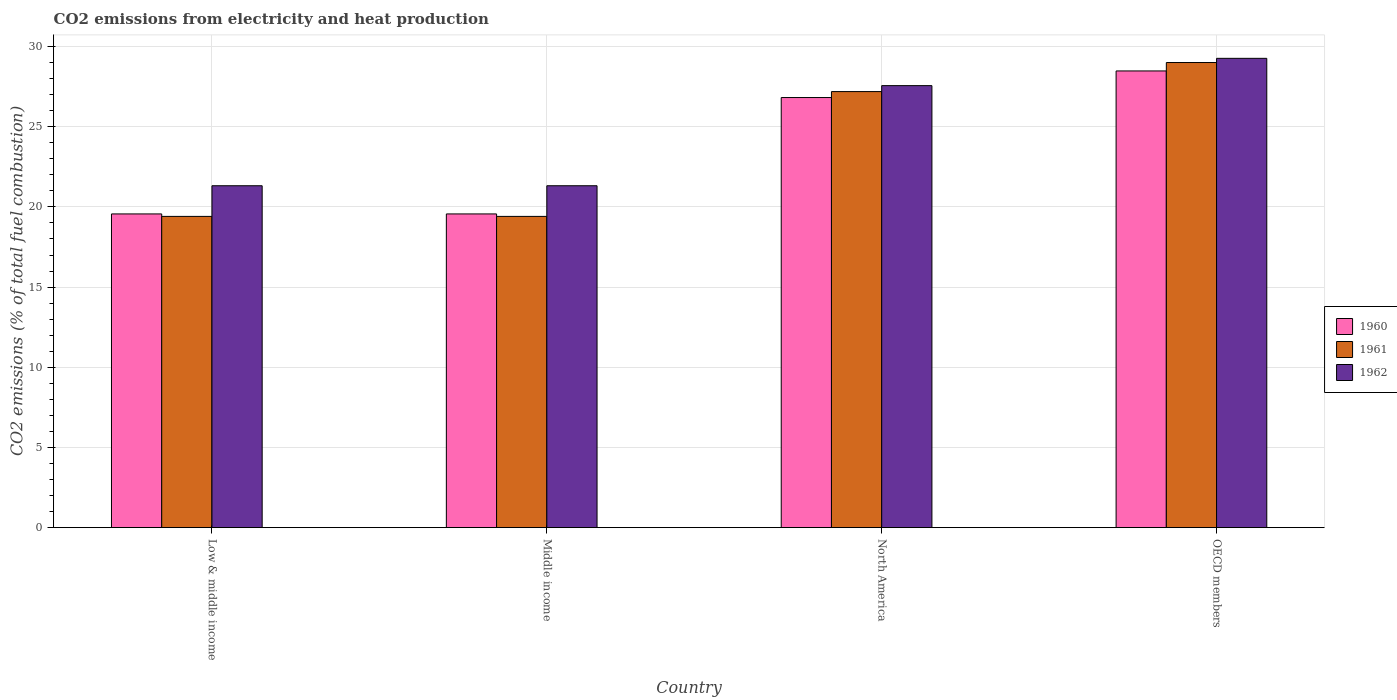How many different coloured bars are there?
Offer a very short reply. 3. How many bars are there on the 4th tick from the left?
Provide a succinct answer. 3. How many bars are there on the 3rd tick from the right?
Your answer should be compact. 3. What is the amount of CO2 emitted in 1961 in OECD members?
Keep it short and to the point. 29. Across all countries, what is the maximum amount of CO2 emitted in 1962?
Offer a terse response. 29.26. Across all countries, what is the minimum amount of CO2 emitted in 1962?
Offer a terse response. 21.32. In which country was the amount of CO2 emitted in 1960 maximum?
Provide a succinct answer. OECD members. In which country was the amount of CO2 emitted in 1961 minimum?
Offer a terse response. Low & middle income. What is the total amount of CO2 emitted in 1960 in the graph?
Your answer should be compact. 94.43. What is the difference between the amount of CO2 emitted in 1961 in North America and that in OECD members?
Your answer should be very brief. -1.81. What is the difference between the amount of CO2 emitted in 1960 in Middle income and the amount of CO2 emitted in 1962 in OECD members?
Make the answer very short. -9.7. What is the average amount of CO2 emitted in 1962 per country?
Make the answer very short. 24.87. What is the difference between the amount of CO2 emitted of/in 1962 and amount of CO2 emitted of/in 1961 in Low & middle income?
Your response must be concise. 1.91. In how many countries, is the amount of CO2 emitted in 1960 greater than 2 %?
Provide a succinct answer. 4. What is the ratio of the amount of CO2 emitted in 1960 in North America to that in OECD members?
Offer a terse response. 0.94. Is the amount of CO2 emitted in 1961 in Middle income less than that in North America?
Ensure brevity in your answer.  Yes. What is the difference between the highest and the second highest amount of CO2 emitted in 1962?
Your response must be concise. -6.24. What is the difference between the highest and the lowest amount of CO2 emitted in 1961?
Your answer should be very brief. 9.6. Is the sum of the amount of CO2 emitted in 1962 in North America and OECD members greater than the maximum amount of CO2 emitted in 1960 across all countries?
Offer a very short reply. Yes. What does the 3rd bar from the right in Low & middle income represents?
Provide a short and direct response. 1960. How many countries are there in the graph?
Keep it short and to the point. 4. Are the values on the major ticks of Y-axis written in scientific E-notation?
Provide a short and direct response. No. Does the graph contain grids?
Your response must be concise. Yes. Where does the legend appear in the graph?
Keep it short and to the point. Center right. How are the legend labels stacked?
Your answer should be very brief. Vertical. What is the title of the graph?
Your answer should be compact. CO2 emissions from electricity and heat production. Does "1965" appear as one of the legend labels in the graph?
Offer a terse response. No. What is the label or title of the Y-axis?
Your response must be concise. CO2 emissions (% of total fuel combustion). What is the CO2 emissions (% of total fuel combustion) in 1960 in Low & middle income?
Your response must be concise. 19.56. What is the CO2 emissions (% of total fuel combustion) of 1961 in Low & middle income?
Your answer should be compact. 19.41. What is the CO2 emissions (% of total fuel combustion) of 1962 in Low & middle income?
Give a very brief answer. 21.32. What is the CO2 emissions (% of total fuel combustion) of 1960 in Middle income?
Give a very brief answer. 19.56. What is the CO2 emissions (% of total fuel combustion) of 1961 in Middle income?
Make the answer very short. 19.41. What is the CO2 emissions (% of total fuel combustion) of 1962 in Middle income?
Your answer should be compact. 21.32. What is the CO2 emissions (% of total fuel combustion) of 1960 in North America?
Ensure brevity in your answer.  26.82. What is the CO2 emissions (% of total fuel combustion) of 1961 in North America?
Your response must be concise. 27.19. What is the CO2 emissions (% of total fuel combustion) of 1962 in North America?
Keep it short and to the point. 27.56. What is the CO2 emissions (% of total fuel combustion) of 1960 in OECD members?
Ensure brevity in your answer.  28.48. What is the CO2 emissions (% of total fuel combustion) of 1961 in OECD members?
Keep it short and to the point. 29. What is the CO2 emissions (% of total fuel combustion) in 1962 in OECD members?
Offer a terse response. 29.26. Across all countries, what is the maximum CO2 emissions (% of total fuel combustion) of 1960?
Offer a terse response. 28.48. Across all countries, what is the maximum CO2 emissions (% of total fuel combustion) in 1961?
Your response must be concise. 29. Across all countries, what is the maximum CO2 emissions (% of total fuel combustion) of 1962?
Your answer should be very brief. 29.26. Across all countries, what is the minimum CO2 emissions (% of total fuel combustion) in 1960?
Make the answer very short. 19.56. Across all countries, what is the minimum CO2 emissions (% of total fuel combustion) of 1961?
Give a very brief answer. 19.41. Across all countries, what is the minimum CO2 emissions (% of total fuel combustion) of 1962?
Provide a short and direct response. 21.32. What is the total CO2 emissions (% of total fuel combustion) in 1960 in the graph?
Provide a succinct answer. 94.42. What is the total CO2 emissions (% of total fuel combustion) in 1961 in the graph?
Provide a short and direct response. 95.01. What is the total CO2 emissions (% of total fuel combustion) of 1962 in the graph?
Your answer should be compact. 99.47. What is the difference between the CO2 emissions (% of total fuel combustion) in 1960 in Low & middle income and that in Middle income?
Keep it short and to the point. 0. What is the difference between the CO2 emissions (% of total fuel combustion) in 1962 in Low & middle income and that in Middle income?
Give a very brief answer. 0. What is the difference between the CO2 emissions (% of total fuel combustion) of 1960 in Low & middle income and that in North America?
Provide a short and direct response. -7.26. What is the difference between the CO2 emissions (% of total fuel combustion) of 1961 in Low & middle income and that in North America?
Offer a very short reply. -7.78. What is the difference between the CO2 emissions (% of total fuel combustion) in 1962 in Low & middle income and that in North America?
Offer a very short reply. -6.24. What is the difference between the CO2 emissions (% of total fuel combustion) of 1960 in Low & middle income and that in OECD members?
Your answer should be compact. -8.92. What is the difference between the CO2 emissions (% of total fuel combustion) of 1961 in Low & middle income and that in OECD members?
Your response must be concise. -9.6. What is the difference between the CO2 emissions (% of total fuel combustion) of 1962 in Low & middle income and that in OECD members?
Your answer should be compact. -7.95. What is the difference between the CO2 emissions (% of total fuel combustion) in 1960 in Middle income and that in North America?
Offer a very short reply. -7.26. What is the difference between the CO2 emissions (% of total fuel combustion) in 1961 in Middle income and that in North America?
Ensure brevity in your answer.  -7.78. What is the difference between the CO2 emissions (% of total fuel combustion) of 1962 in Middle income and that in North America?
Ensure brevity in your answer.  -6.24. What is the difference between the CO2 emissions (% of total fuel combustion) of 1960 in Middle income and that in OECD members?
Offer a very short reply. -8.92. What is the difference between the CO2 emissions (% of total fuel combustion) of 1961 in Middle income and that in OECD members?
Give a very brief answer. -9.6. What is the difference between the CO2 emissions (% of total fuel combustion) in 1962 in Middle income and that in OECD members?
Provide a short and direct response. -7.95. What is the difference between the CO2 emissions (% of total fuel combustion) of 1960 in North America and that in OECD members?
Your answer should be very brief. -1.66. What is the difference between the CO2 emissions (% of total fuel combustion) of 1961 in North America and that in OECD members?
Provide a short and direct response. -1.81. What is the difference between the CO2 emissions (% of total fuel combustion) in 1962 in North America and that in OECD members?
Your answer should be compact. -1.7. What is the difference between the CO2 emissions (% of total fuel combustion) of 1960 in Low & middle income and the CO2 emissions (% of total fuel combustion) of 1961 in Middle income?
Your answer should be compact. 0.15. What is the difference between the CO2 emissions (% of total fuel combustion) in 1960 in Low & middle income and the CO2 emissions (% of total fuel combustion) in 1962 in Middle income?
Your answer should be compact. -1.76. What is the difference between the CO2 emissions (% of total fuel combustion) in 1961 in Low & middle income and the CO2 emissions (% of total fuel combustion) in 1962 in Middle income?
Your answer should be very brief. -1.91. What is the difference between the CO2 emissions (% of total fuel combustion) in 1960 in Low & middle income and the CO2 emissions (% of total fuel combustion) in 1961 in North America?
Offer a terse response. -7.63. What is the difference between the CO2 emissions (% of total fuel combustion) in 1960 in Low & middle income and the CO2 emissions (% of total fuel combustion) in 1962 in North America?
Keep it short and to the point. -8. What is the difference between the CO2 emissions (% of total fuel combustion) in 1961 in Low & middle income and the CO2 emissions (% of total fuel combustion) in 1962 in North America?
Your answer should be compact. -8.15. What is the difference between the CO2 emissions (% of total fuel combustion) in 1960 in Low & middle income and the CO2 emissions (% of total fuel combustion) in 1961 in OECD members?
Offer a very short reply. -9.44. What is the difference between the CO2 emissions (% of total fuel combustion) of 1960 in Low & middle income and the CO2 emissions (% of total fuel combustion) of 1962 in OECD members?
Your answer should be compact. -9.7. What is the difference between the CO2 emissions (% of total fuel combustion) of 1961 in Low & middle income and the CO2 emissions (% of total fuel combustion) of 1962 in OECD members?
Keep it short and to the point. -9.86. What is the difference between the CO2 emissions (% of total fuel combustion) of 1960 in Middle income and the CO2 emissions (% of total fuel combustion) of 1961 in North America?
Your response must be concise. -7.63. What is the difference between the CO2 emissions (% of total fuel combustion) of 1960 in Middle income and the CO2 emissions (% of total fuel combustion) of 1962 in North America?
Make the answer very short. -8. What is the difference between the CO2 emissions (% of total fuel combustion) of 1961 in Middle income and the CO2 emissions (% of total fuel combustion) of 1962 in North America?
Keep it short and to the point. -8.15. What is the difference between the CO2 emissions (% of total fuel combustion) of 1960 in Middle income and the CO2 emissions (% of total fuel combustion) of 1961 in OECD members?
Ensure brevity in your answer.  -9.44. What is the difference between the CO2 emissions (% of total fuel combustion) of 1960 in Middle income and the CO2 emissions (% of total fuel combustion) of 1962 in OECD members?
Provide a succinct answer. -9.7. What is the difference between the CO2 emissions (% of total fuel combustion) in 1961 in Middle income and the CO2 emissions (% of total fuel combustion) in 1962 in OECD members?
Make the answer very short. -9.86. What is the difference between the CO2 emissions (% of total fuel combustion) of 1960 in North America and the CO2 emissions (% of total fuel combustion) of 1961 in OECD members?
Offer a very short reply. -2.18. What is the difference between the CO2 emissions (% of total fuel combustion) of 1960 in North America and the CO2 emissions (% of total fuel combustion) of 1962 in OECD members?
Your response must be concise. -2.44. What is the difference between the CO2 emissions (% of total fuel combustion) of 1961 in North America and the CO2 emissions (% of total fuel combustion) of 1962 in OECD members?
Provide a short and direct response. -2.07. What is the average CO2 emissions (% of total fuel combustion) of 1960 per country?
Your response must be concise. 23.61. What is the average CO2 emissions (% of total fuel combustion) of 1961 per country?
Your response must be concise. 23.75. What is the average CO2 emissions (% of total fuel combustion) of 1962 per country?
Make the answer very short. 24.87. What is the difference between the CO2 emissions (% of total fuel combustion) of 1960 and CO2 emissions (% of total fuel combustion) of 1961 in Low & middle income?
Ensure brevity in your answer.  0.15. What is the difference between the CO2 emissions (% of total fuel combustion) of 1960 and CO2 emissions (% of total fuel combustion) of 1962 in Low & middle income?
Provide a short and direct response. -1.76. What is the difference between the CO2 emissions (% of total fuel combustion) in 1961 and CO2 emissions (% of total fuel combustion) in 1962 in Low & middle income?
Keep it short and to the point. -1.91. What is the difference between the CO2 emissions (% of total fuel combustion) in 1960 and CO2 emissions (% of total fuel combustion) in 1961 in Middle income?
Give a very brief answer. 0.15. What is the difference between the CO2 emissions (% of total fuel combustion) in 1960 and CO2 emissions (% of total fuel combustion) in 1962 in Middle income?
Make the answer very short. -1.76. What is the difference between the CO2 emissions (% of total fuel combustion) of 1961 and CO2 emissions (% of total fuel combustion) of 1962 in Middle income?
Your response must be concise. -1.91. What is the difference between the CO2 emissions (% of total fuel combustion) in 1960 and CO2 emissions (% of total fuel combustion) in 1961 in North America?
Your answer should be very brief. -0.37. What is the difference between the CO2 emissions (% of total fuel combustion) of 1960 and CO2 emissions (% of total fuel combustion) of 1962 in North America?
Offer a terse response. -0.74. What is the difference between the CO2 emissions (% of total fuel combustion) of 1961 and CO2 emissions (% of total fuel combustion) of 1962 in North America?
Your response must be concise. -0.37. What is the difference between the CO2 emissions (% of total fuel combustion) of 1960 and CO2 emissions (% of total fuel combustion) of 1961 in OECD members?
Your answer should be compact. -0.52. What is the difference between the CO2 emissions (% of total fuel combustion) of 1960 and CO2 emissions (% of total fuel combustion) of 1962 in OECD members?
Your answer should be compact. -0.79. What is the difference between the CO2 emissions (% of total fuel combustion) in 1961 and CO2 emissions (% of total fuel combustion) in 1962 in OECD members?
Your answer should be very brief. -0.26. What is the ratio of the CO2 emissions (% of total fuel combustion) in 1961 in Low & middle income to that in Middle income?
Offer a terse response. 1. What is the ratio of the CO2 emissions (% of total fuel combustion) of 1960 in Low & middle income to that in North America?
Provide a succinct answer. 0.73. What is the ratio of the CO2 emissions (% of total fuel combustion) of 1961 in Low & middle income to that in North America?
Provide a short and direct response. 0.71. What is the ratio of the CO2 emissions (% of total fuel combustion) in 1962 in Low & middle income to that in North America?
Provide a short and direct response. 0.77. What is the ratio of the CO2 emissions (% of total fuel combustion) in 1960 in Low & middle income to that in OECD members?
Give a very brief answer. 0.69. What is the ratio of the CO2 emissions (% of total fuel combustion) in 1961 in Low & middle income to that in OECD members?
Your answer should be very brief. 0.67. What is the ratio of the CO2 emissions (% of total fuel combustion) of 1962 in Low & middle income to that in OECD members?
Provide a succinct answer. 0.73. What is the ratio of the CO2 emissions (% of total fuel combustion) of 1960 in Middle income to that in North America?
Offer a very short reply. 0.73. What is the ratio of the CO2 emissions (% of total fuel combustion) of 1961 in Middle income to that in North America?
Provide a succinct answer. 0.71. What is the ratio of the CO2 emissions (% of total fuel combustion) in 1962 in Middle income to that in North America?
Your answer should be compact. 0.77. What is the ratio of the CO2 emissions (% of total fuel combustion) in 1960 in Middle income to that in OECD members?
Your answer should be very brief. 0.69. What is the ratio of the CO2 emissions (% of total fuel combustion) of 1961 in Middle income to that in OECD members?
Ensure brevity in your answer.  0.67. What is the ratio of the CO2 emissions (% of total fuel combustion) in 1962 in Middle income to that in OECD members?
Ensure brevity in your answer.  0.73. What is the ratio of the CO2 emissions (% of total fuel combustion) in 1960 in North America to that in OECD members?
Keep it short and to the point. 0.94. What is the ratio of the CO2 emissions (% of total fuel combustion) of 1961 in North America to that in OECD members?
Make the answer very short. 0.94. What is the ratio of the CO2 emissions (% of total fuel combustion) of 1962 in North America to that in OECD members?
Ensure brevity in your answer.  0.94. What is the difference between the highest and the second highest CO2 emissions (% of total fuel combustion) of 1960?
Your response must be concise. 1.66. What is the difference between the highest and the second highest CO2 emissions (% of total fuel combustion) of 1961?
Your answer should be very brief. 1.81. What is the difference between the highest and the second highest CO2 emissions (% of total fuel combustion) in 1962?
Offer a terse response. 1.7. What is the difference between the highest and the lowest CO2 emissions (% of total fuel combustion) of 1960?
Make the answer very short. 8.92. What is the difference between the highest and the lowest CO2 emissions (% of total fuel combustion) of 1961?
Your answer should be compact. 9.6. What is the difference between the highest and the lowest CO2 emissions (% of total fuel combustion) in 1962?
Offer a very short reply. 7.95. 